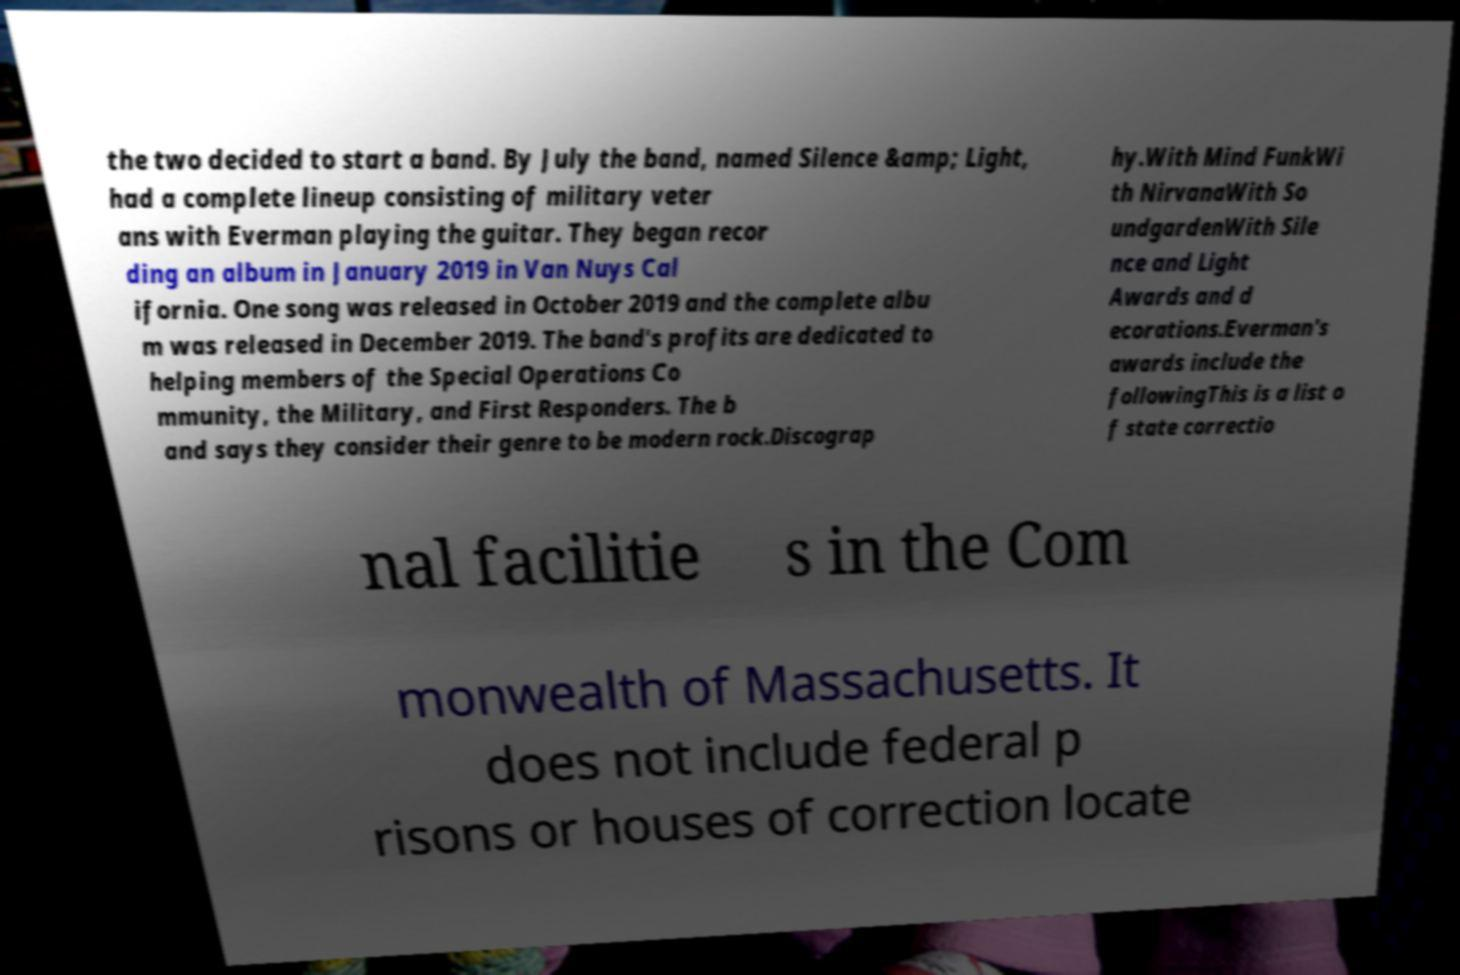There's text embedded in this image that I need extracted. Can you transcribe it verbatim? the two decided to start a band. By July the band, named Silence &amp; Light, had a complete lineup consisting of military veter ans with Everman playing the guitar. They began recor ding an album in January 2019 in Van Nuys Cal ifornia. One song was released in October 2019 and the complete albu m was released in December 2019. The band's profits are dedicated to helping members of the Special Operations Co mmunity, the Military, and First Responders. The b and says they consider their genre to be modern rock.Discograp hy.With Mind FunkWi th NirvanaWith So undgardenWith Sile nce and Light Awards and d ecorations.Everman's awards include the followingThis is a list o f state correctio nal facilitie s in the Com monwealth of Massachusetts. It does not include federal p risons or houses of correction locate 